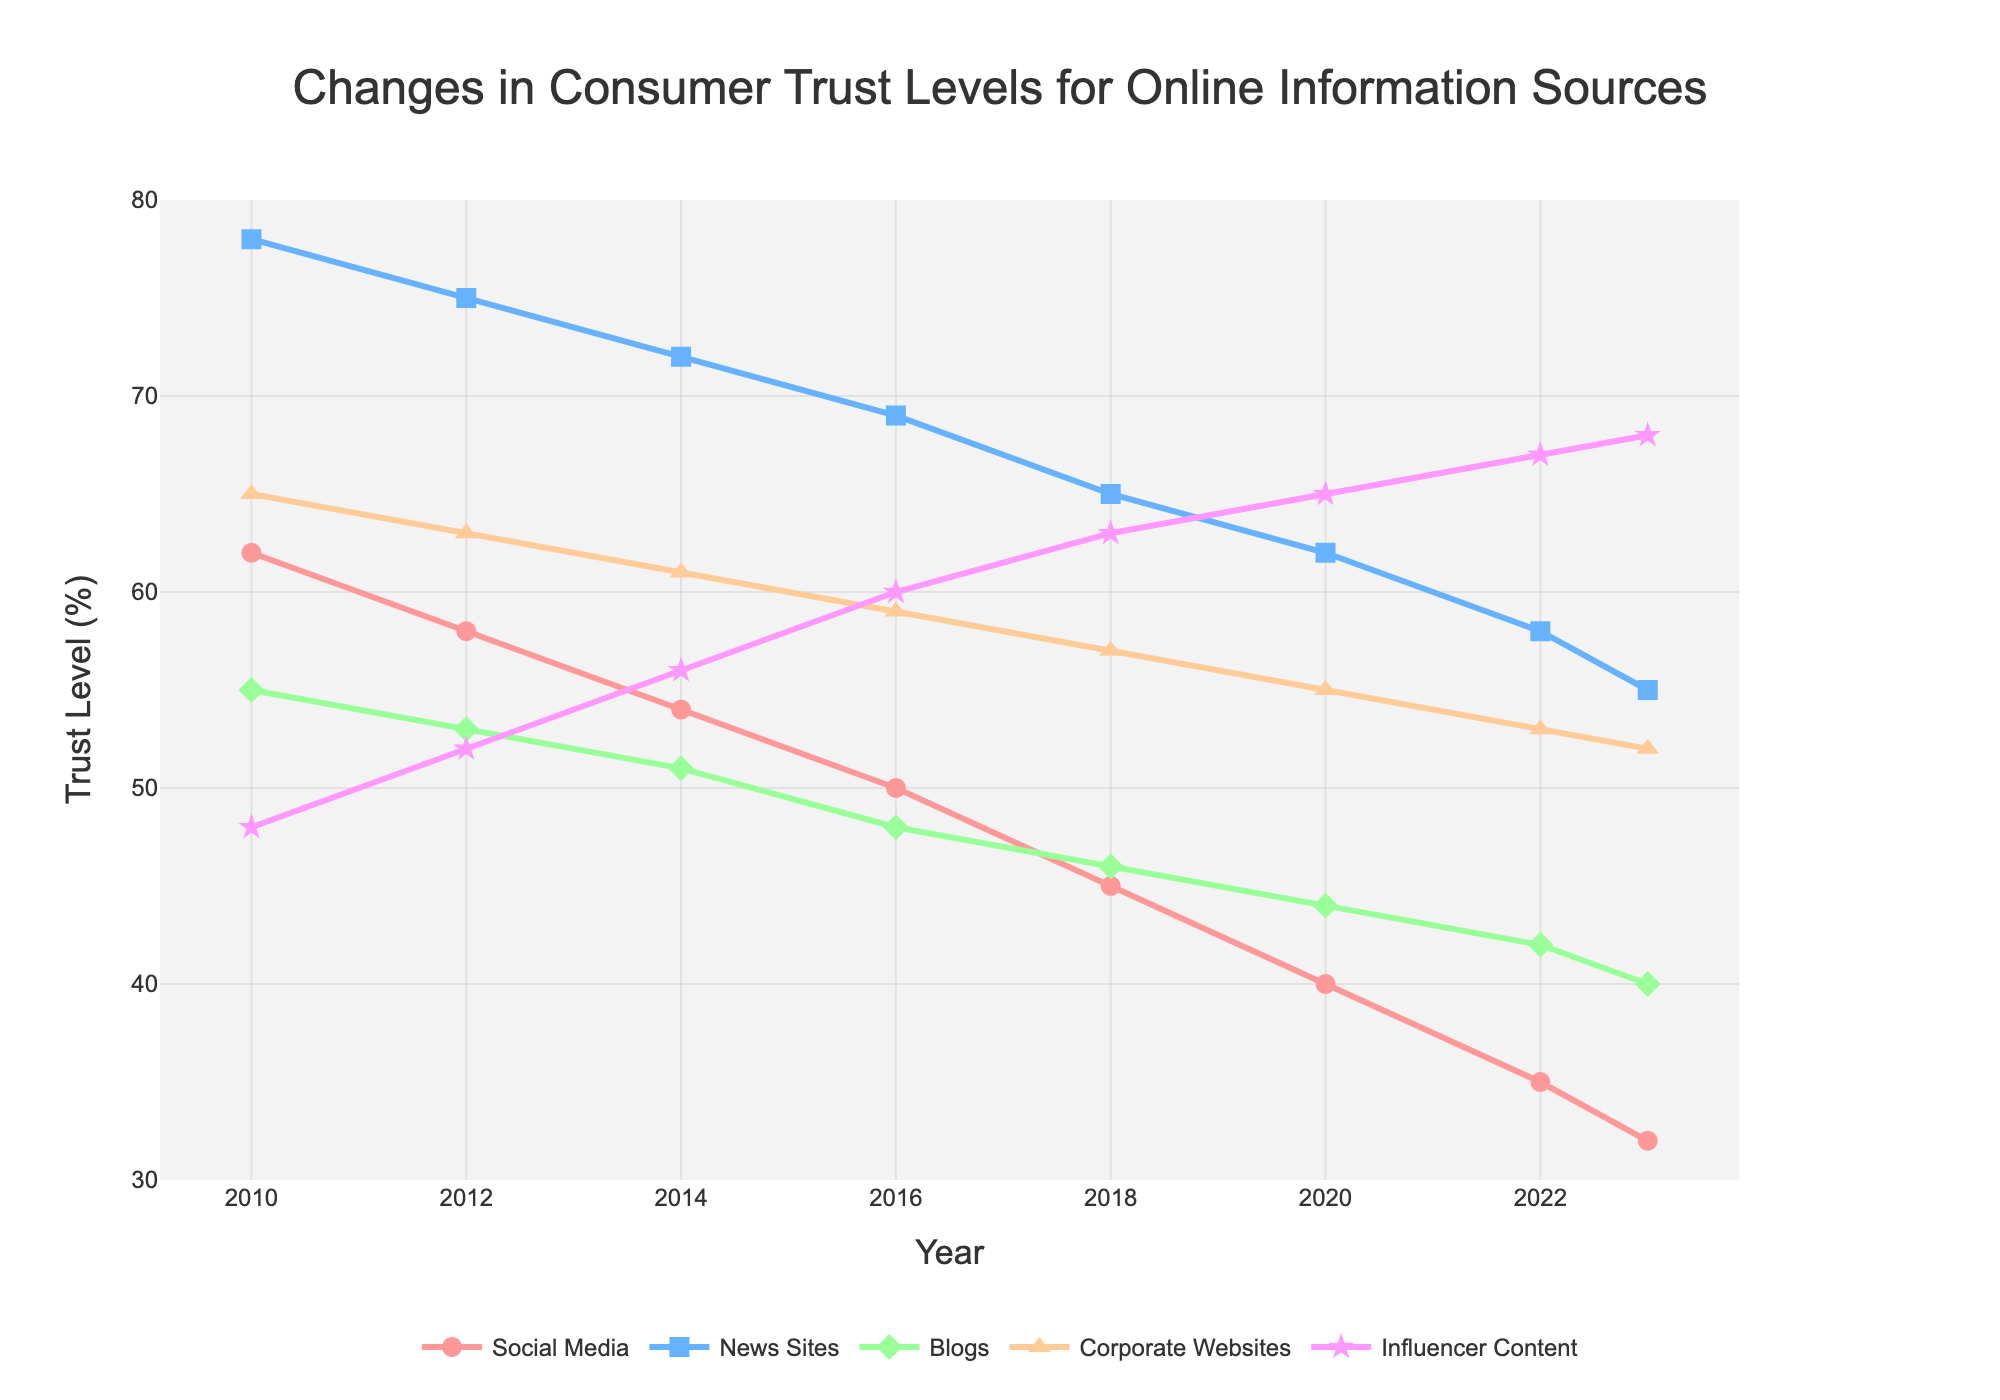What was the trust level in News Sites in 2018? Locate the point corresponding to 2018 on the x-axis and find the associated value for News Sites (blue line). The trust level for News Sites in 2018 is 65.
Answer: 65 Which information source had the highest trust level in 2023? Compare the values for all information sources at the year 2023. The source with the highest trust level (value close to 70) is Influencer Content (purple line).
Answer: Influencer Content How has the trust level in Blogs changed from 2010 to 2023? Identify the values at 2010 and 2023 for Blogs (green line), and calculate the difference: 55 (2010) - 40 (2023) = 15. The trust level has decreased by 15 percentage points.
Answer: Decreased by 15 points What is the overall trend for Social Media trust levels from 2010 to 2023? Observe the trajectory of the Social Media line (red line) from 2010 to 2023. The trend shows a consistent decline.
Answer: Declining Which year did Influencer Content surpass Corporate Websites in trust levels? Compare the values for Influencer Content and Corporate Websites (orange line) across the years. Influencer Content overtakes Corporate Websites around 2016.
Answer: 2016 Is there any year where Blogs had the same trust level as another information source? Examine the lines for all information sources over the years. In 2016, Blogs (green line) and Influencer Content (purple line) both had a trust level of 48.
Answer: 2016 What is the average trust level for Corporate Websites from 2010 to 2023? Sum the trust levels for Corporate Websites from 2010 to 2023 (65+63+61+59+57+55+53+52) and divide by the number of years (8). The average is (65+63+61+59+57+55+53+52)/8 = 58.1.
Answer: 58.1 Compare the decline rate of trust in Social Media vs News Sites between 2010 and 2023. Calculate the decline in trust levels: Social Media (62-32 = 30 points) and News Sites (78-55 = 23 points). Social Media has a higher rate of decline.
Answer: Social Media By how much did trust in Influencer Content increase from 2010 to 2023? Find the difference in the trust levels for Influencer Content between 2010 (48) and 2023 (68). The increase is 68 - 48 = 20 percentage points.
Answer: 20 points 